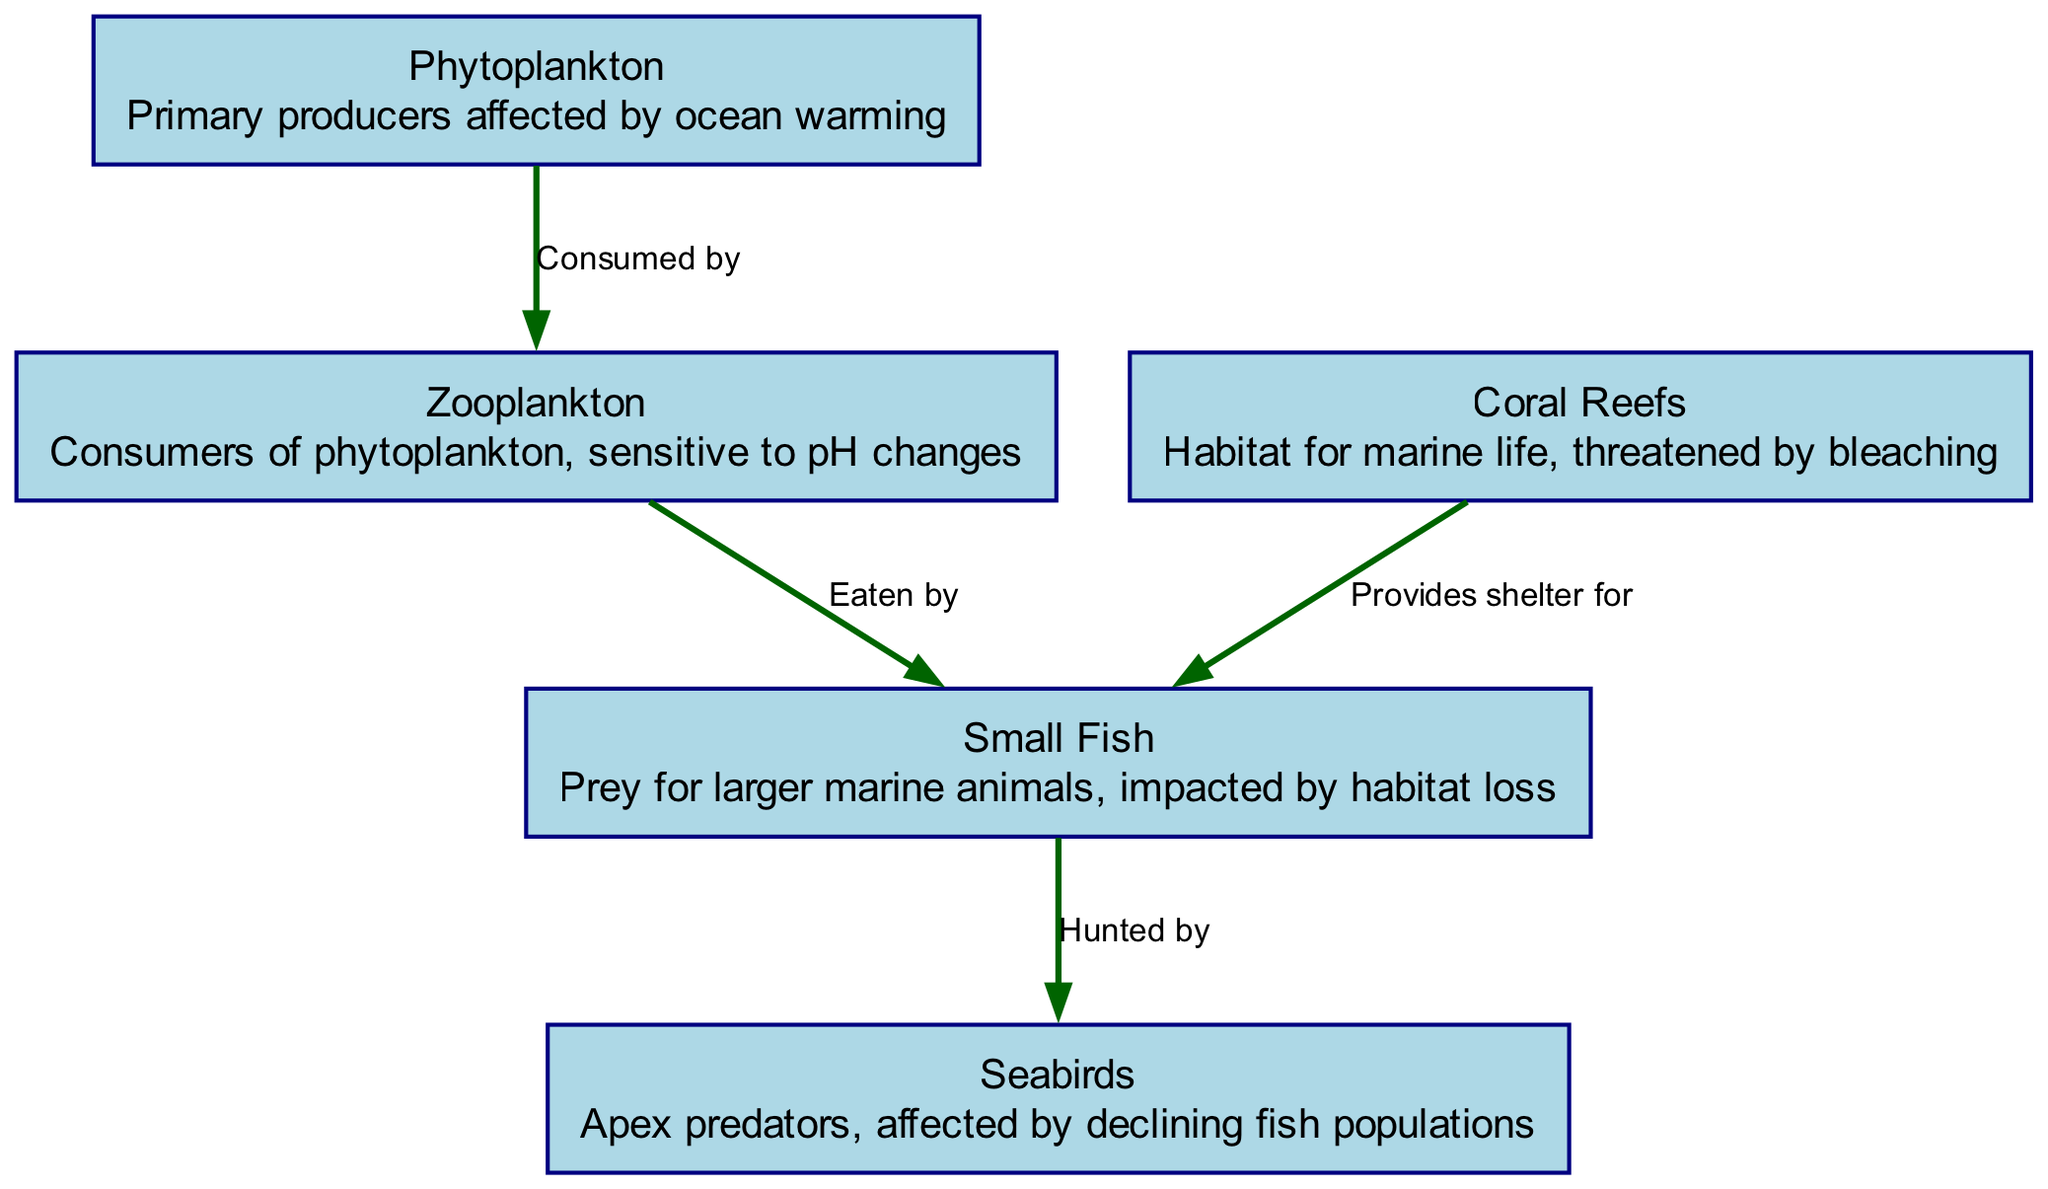What is the primary producer in this food chain? The diagram shows "Phytoplankton" as the first node, which is described as the primary producers affected by ocean warming. Since it is at the beginning of the food chain, it indicates its role as the primary producer.
Answer: Phytoplankton How many nodes are present in the diagram? By counting the distinct entities represented, there are five nodes listed: Phytoplankton, Zooplankton, Small Fish, Seabirds, and Coral Reefs, which totals to five.
Answer: 5 Which two organisms are connected by the edge labeled "Eaten by"? The edge labeled "Eaten by" is between "Zooplankton" (source) and "Small Fish" (target). The label indicates that zooplankton are the prey being consumed by small fish in the food chain.
Answer: Zooplankton and Small Fish What is the role of Coral Reefs in this food chain? According to the diagram, Coral Reefs provide shelter for Small Fish, meaning they act as a habitat or safe space for this species in the marine ecosystem.
Answer: Provides shelter for How many edges connect the nodes in this diagram? The diagram displays a total of four connections or edges: from Phytoplankton to Zooplankton, Zooplankton to Small Fish, Small Fish to Seabirds, and Coral Reefs to Small Fish. This indicates that there are four distinct relationships defined within the food chain.
Answer: 4 What happens to Seabirds as a result of declining fish populations? The diagram indicates that Seabirds, being apex predators, are affected by declining fish populations, implying they may face challenges in finding enough food due to this decline.
Answer: Affected by declining fish populations Which nodes are impacted by climate change-related threats? Both Phytoplankton and Coral Reefs are highlighted as being affected by climate change, with phytoplankton facing issues due to ocean warming and coral reefs threatened by bleaching.
Answer: Phytoplankton and Coral Reefs What type of relationship exists between Small Fish and Seabirds? In the diagram, Small Fish are "Hunted by" Seabirds, indicating a predator-prey relationship: seabirds rely on small fish as an important food source within the marine food chain.
Answer: Hunted by 